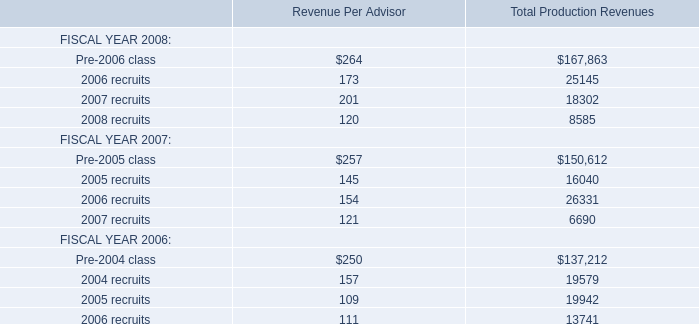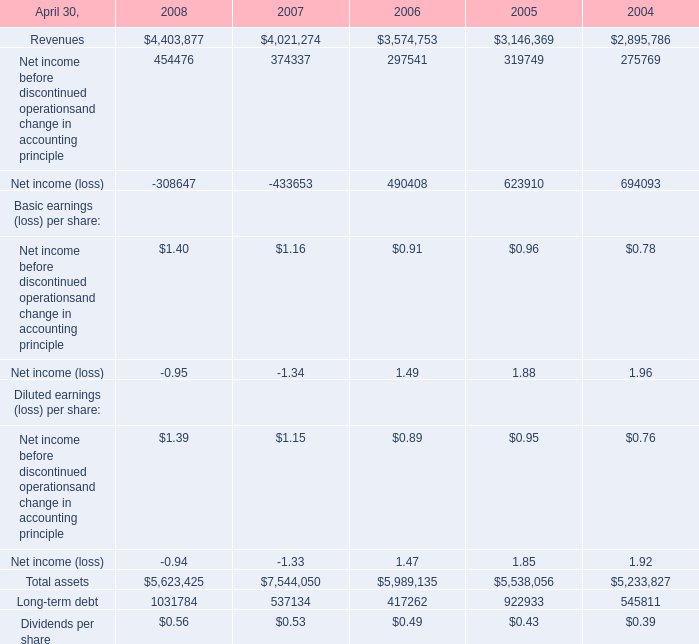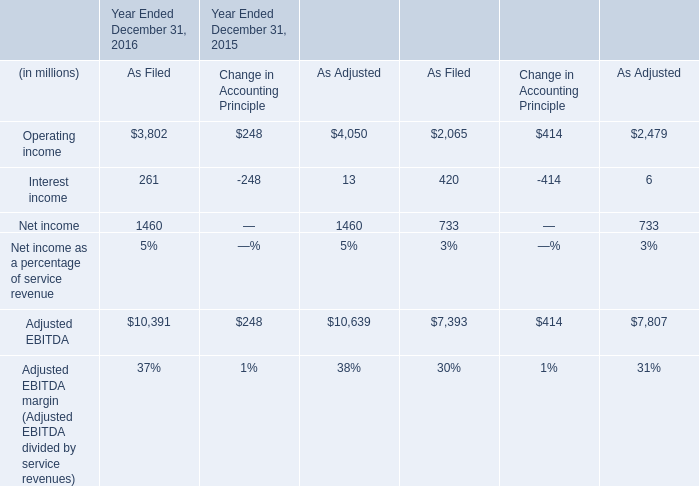At April 30,what year is Long-term debt greater than 1000000? 
Answer: 2008. 